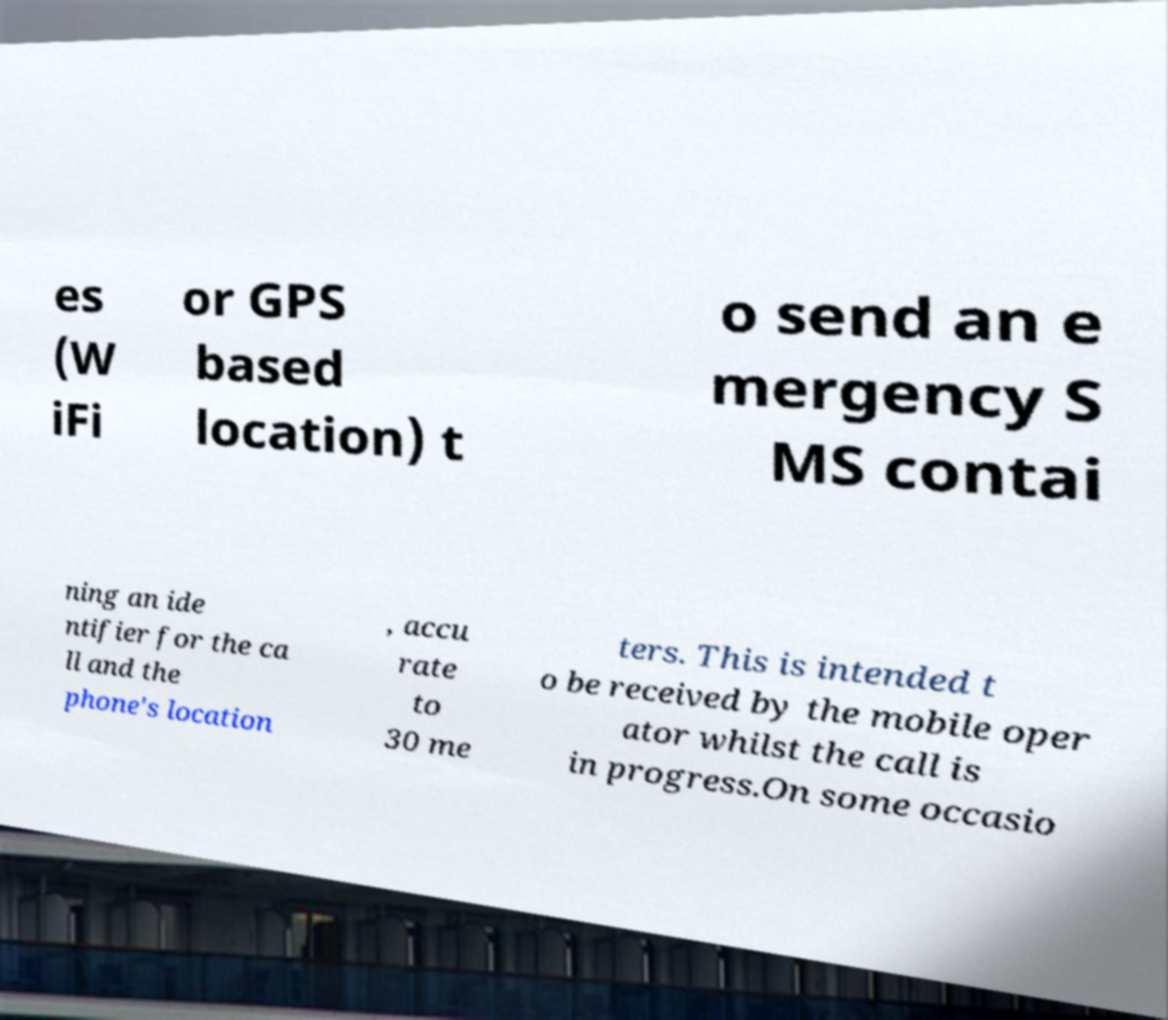For documentation purposes, I need the text within this image transcribed. Could you provide that? es (W iFi or GPS based location) t o send an e mergency S MS contai ning an ide ntifier for the ca ll and the phone's location , accu rate to 30 me ters. This is intended t o be received by the mobile oper ator whilst the call is in progress.On some occasio 